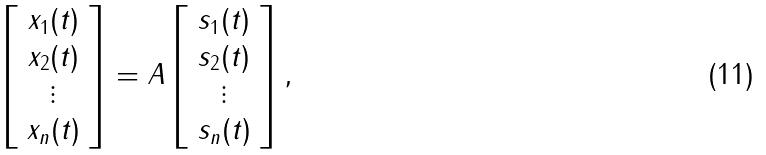Convert formula to latex. <formula><loc_0><loc_0><loc_500><loc_500>\left [ \begin{array} { c } x _ { 1 } ( t ) \\ x _ { 2 } ( t ) \\ \vdots \\ x _ { n } ( t ) \end{array} \right ] = A \left [ \begin{array} { c } s _ { 1 } ( t ) \\ s _ { 2 } ( t ) \\ \vdots \\ s _ { n } ( t ) \end{array} \right ] ,</formula> 